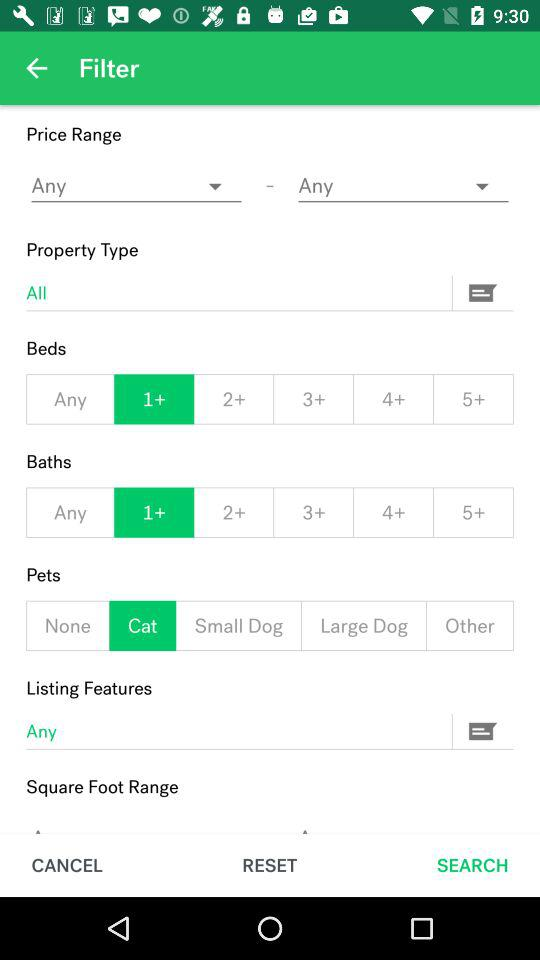What is the number of baths selected? The number of baths selected is 1+. 